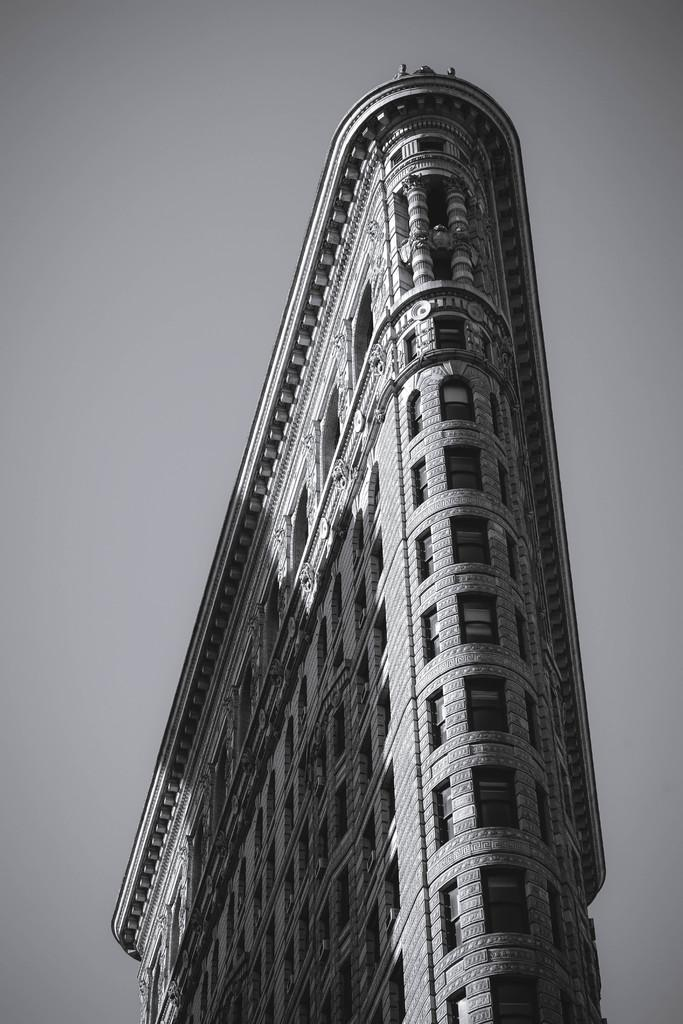What is the color scheme of the image? The image is black and white. What is the main structure in the image? There is a big building in the image. What part of the natural environment is visible in the image? The sky is visible at the top of the image. What type of silver leaf can be seen falling from the sky in the image? There is no silver leaf present in the image; it is a black and white image with a big building and visible sky. 